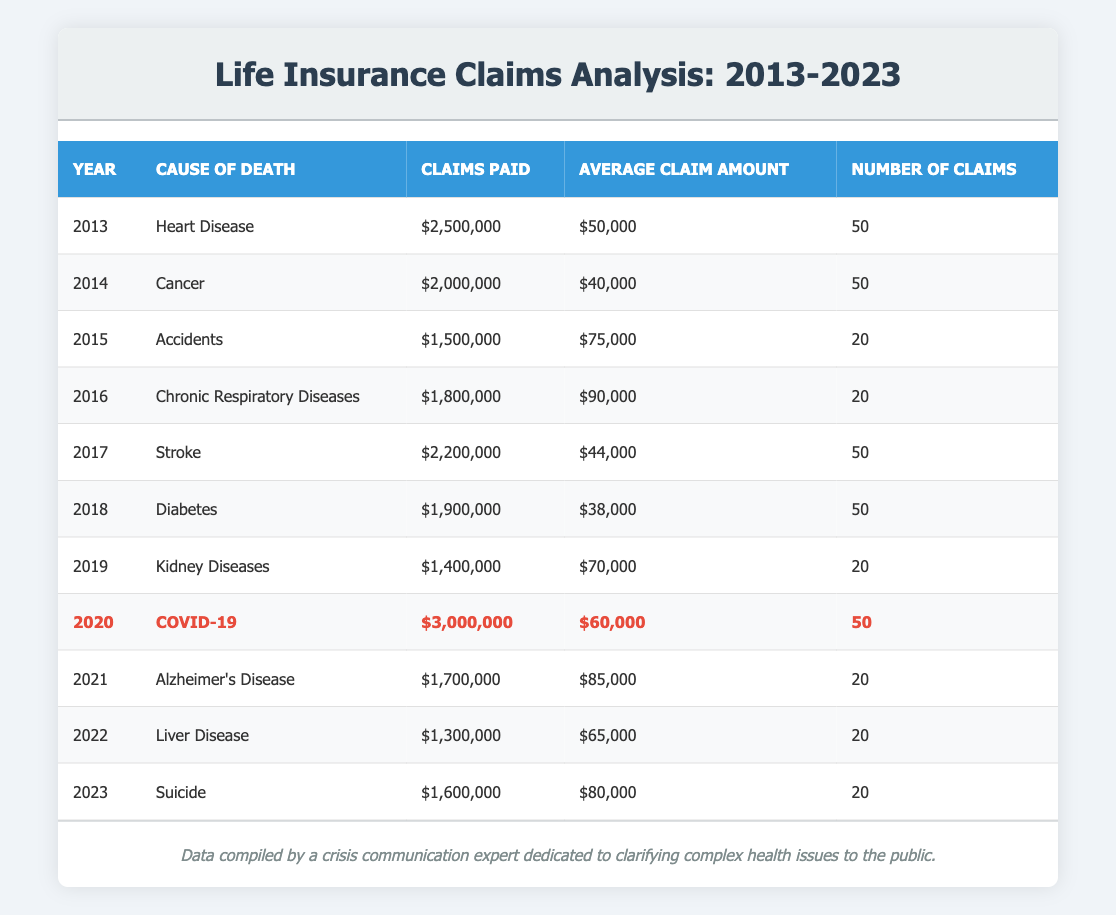What was the total amount of claims paid in 2020? In the table, for the year 2020, the row shows that claims paid due to COVID-19 amounted to $3,000,000. So, the total amount of claims paid in that year is directly taken from this row.
Answer: 3,000,000 Which cause of death had the highest average claim amount over the decade? To find the highest average claim, we check the "Average Claim Amount" column for each cause of death. The highest value is $90,000 related to Chronic Respiratory Diseases in 2016. Comparing all average claim amounts confirms this is the highest.
Answer: Chronic Respiratory Diseases Did the claims paid for Alzheimer's Disease exceed those for Diabetes? For Alzheimer's Disease in 2021, $1,700,000 is paid, while for Diabetes in 2018, $1,900,000 is paid. Since $1,700,000 is less than $1,900,000, it means the claims for Alzheimer's Disease did not exceed those for Diabetes.
Answer: No What is the average claims paid over the decade? We sum the total claims paid from all years: (2,500,000 + 2,000,000 + 1,500,000 + 1,800,000 + 2,200,000 + 1,900,000 + 1,400,000 + 3,000,000 + 1,700,000 + 1,300,000 + 1,600,000) =  22,100,000. We then divide this total by the number of years (11): 22,100,000 / 11 = 2,009,090.91. Thus, the average claims paid over these years is approximately $2,009,090.91.
Answer: 2,009,090.91 How many claims were made in 2015 for accidents? The table shows that there were 20 claims made for accidents in 2015 as indicated in the "Number of Claims" column. This is a direct retrieval from the corresponding row for that year.
Answer: 20 Which year had the highest total claims amount, and what was that amount? By examining the "Claims Paid" column for each year, 2020 stands out with a total amount of $3,000,000 attributed to COVID-19. It is the highest compared to all other years listed.
Answer: 2020, 3,000,000 What were the average claim amounts for the least and most claims made in a single year? The least number of claims in a single year was 20, which occurred in multiple years (2015, 2016, 2019, 2021, 2022, and 2023). The highest number of claims was 50 (2013, 2014, 2017, 2018, 2020). The average for 20 claims is (75,000+90,000+70,000+85,000+65,000+80,000) / 6 = $77,500, while for 50 claims is (50,000 + 40,000 + 44,000 + 38,000 + 60,000) / 5 = $46,400. Thus, the values are $77,500 and $46,400 respectively.
Answer: $77,500 and $46,400 